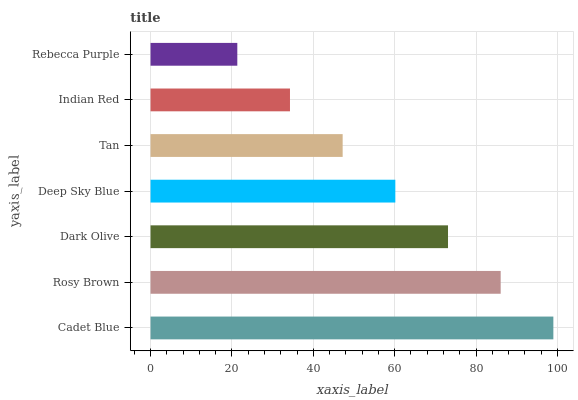Is Rebecca Purple the minimum?
Answer yes or no. Yes. Is Cadet Blue the maximum?
Answer yes or no. Yes. Is Rosy Brown the minimum?
Answer yes or no. No. Is Rosy Brown the maximum?
Answer yes or no. No. Is Cadet Blue greater than Rosy Brown?
Answer yes or no. Yes. Is Rosy Brown less than Cadet Blue?
Answer yes or no. Yes. Is Rosy Brown greater than Cadet Blue?
Answer yes or no. No. Is Cadet Blue less than Rosy Brown?
Answer yes or no. No. Is Deep Sky Blue the high median?
Answer yes or no. Yes. Is Deep Sky Blue the low median?
Answer yes or no. Yes. Is Cadet Blue the high median?
Answer yes or no. No. Is Indian Red the low median?
Answer yes or no. No. 